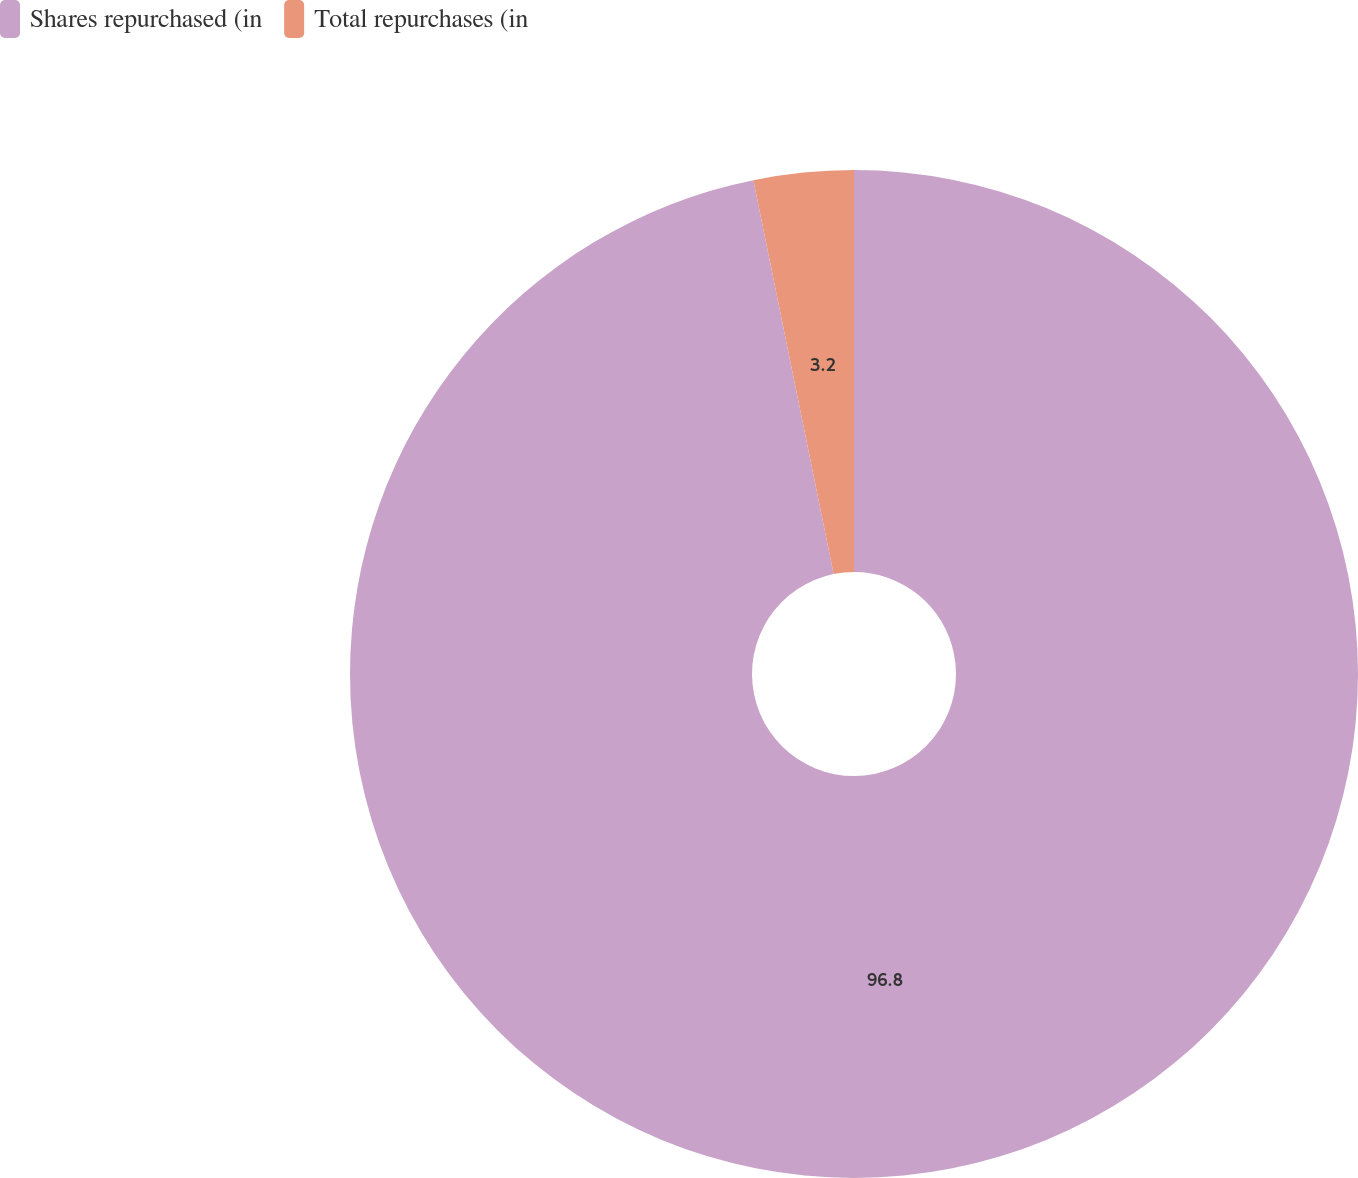Convert chart. <chart><loc_0><loc_0><loc_500><loc_500><pie_chart><fcel>Shares repurchased (in<fcel>Total repurchases (in<nl><fcel>96.8%<fcel>3.2%<nl></chart> 